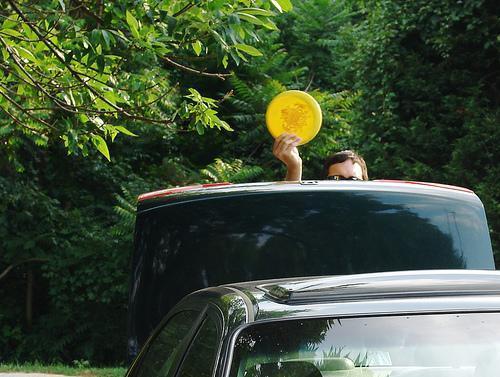How many cars are shown?
Give a very brief answer. 1. How many people are in the picture?
Give a very brief answer. 1. 